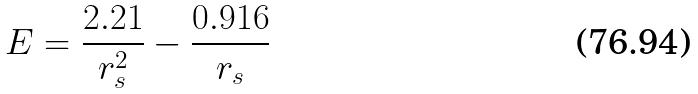Convert formula to latex. <formula><loc_0><loc_0><loc_500><loc_500>E = \frac { 2 . 2 1 } { r _ { s } ^ { 2 } } - \frac { 0 . 9 1 6 } { r _ { s } }</formula> 